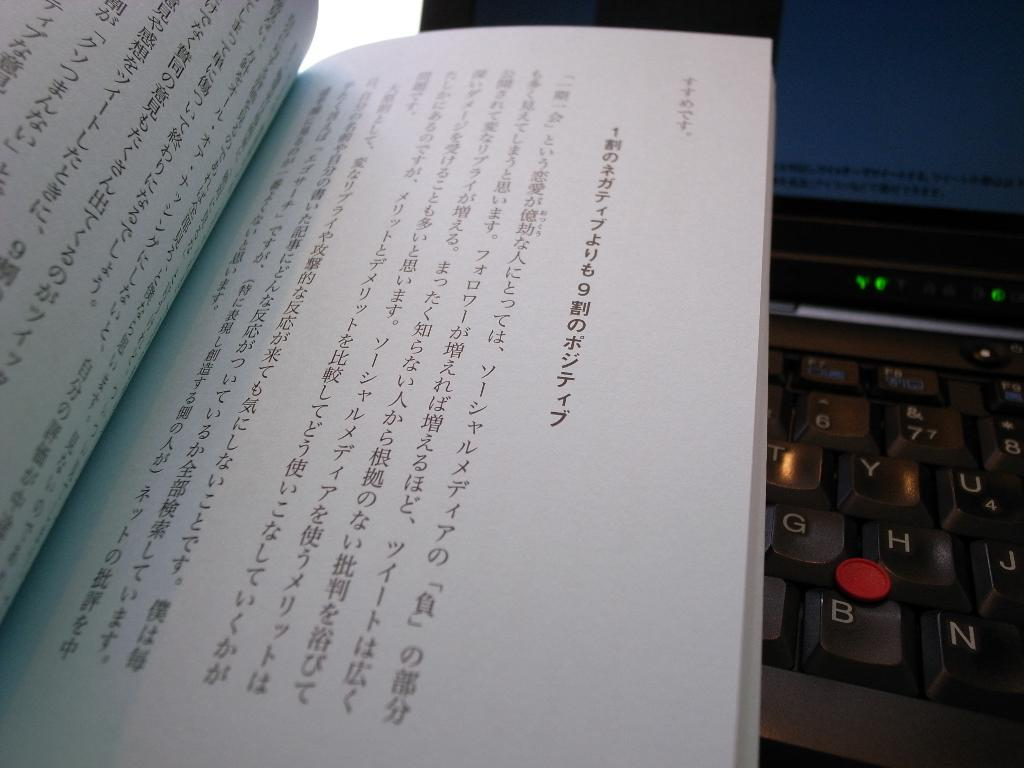<image>
Give a short and clear explanation of the subsequent image. A japanese book is on top of a keyboard with a mouse nib above the B key. 